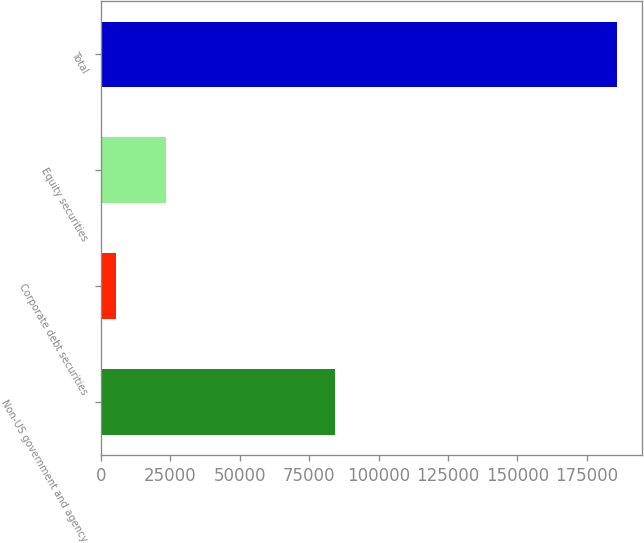Convert chart to OTSL. <chart><loc_0><loc_0><loc_500><loc_500><bar_chart><fcel>Non-US government and agency<fcel>Corporate debt securities<fcel>Equity securities<fcel>Total<nl><fcel>84443<fcel>5495<fcel>23520.4<fcel>185749<nl></chart> 